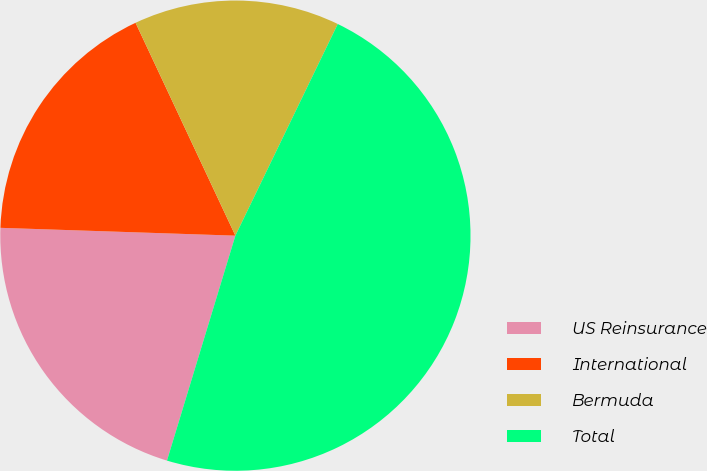Convert chart to OTSL. <chart><loc_0><loc_0><loc_500><loc_500><pie_chart><fcel>US Reinsurance<fcel>International<fcel>Bermuda<fcel>Total<nl><fcel>20.83%<fcel>17.49%<fcel>14.15%<fcel>47.53%<nl></chart> 